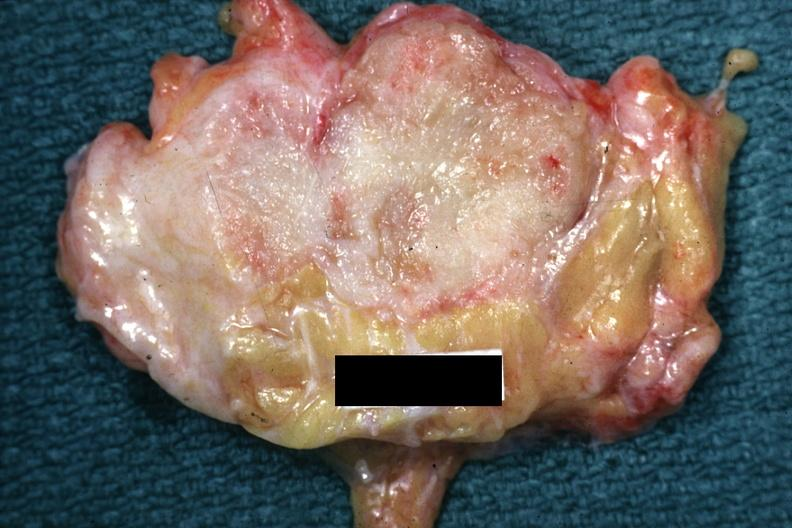what is good example of a breast carcinoma , slide labeled?
Answer the question using a single word or phrase. Labeled cystosarcoma 